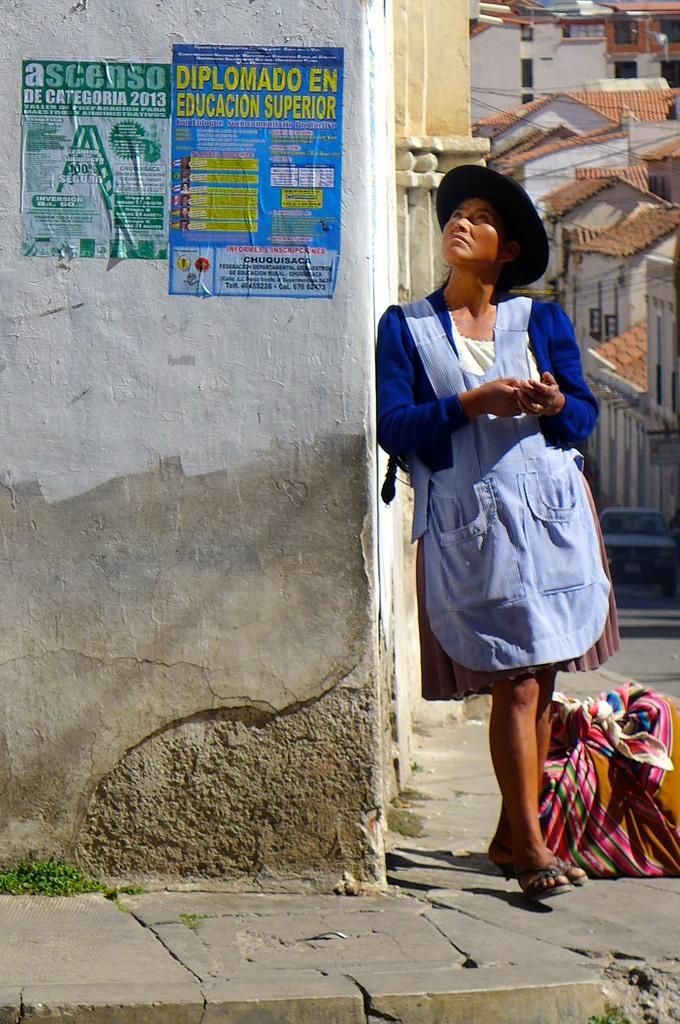In one or two sentences, can you explain what this image depicts? Posters are on the wall. Beside this wall a person is standing. Far there are buildings. 